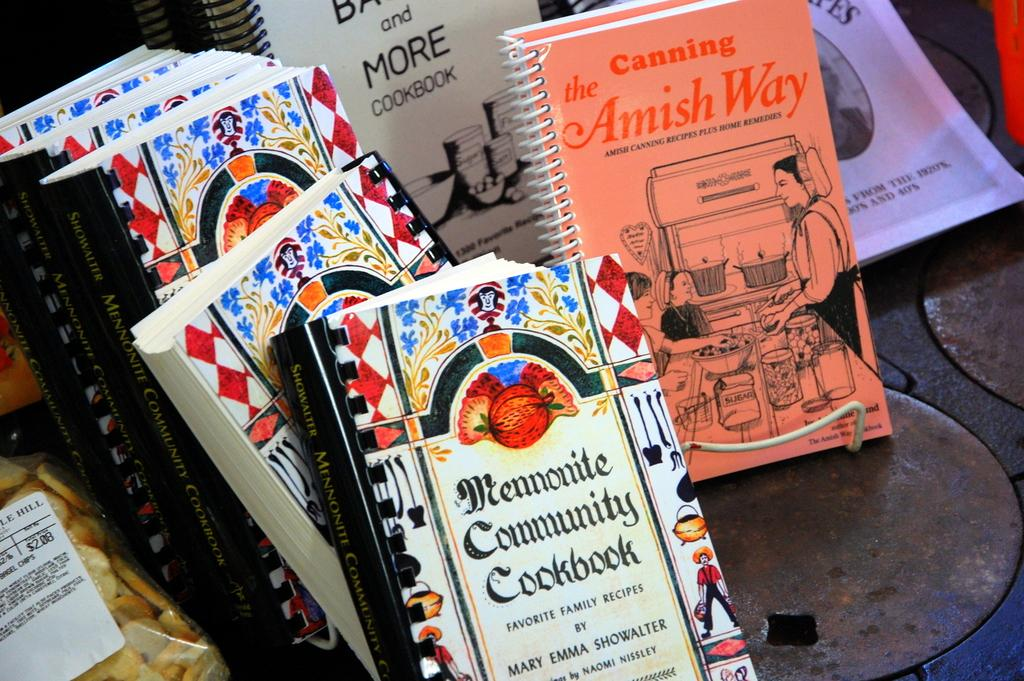<image>
Write a terse but informative summary of the picture. A variety of books which include Canning the Amish Way. 